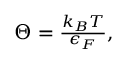<formula> <loc_0><loc_0><loc_500><loc_500>\begin{array} { r } { \Theta = \frac { k _ { B } T } { \epsilon _ { F } } , } \end{array}</formula> 